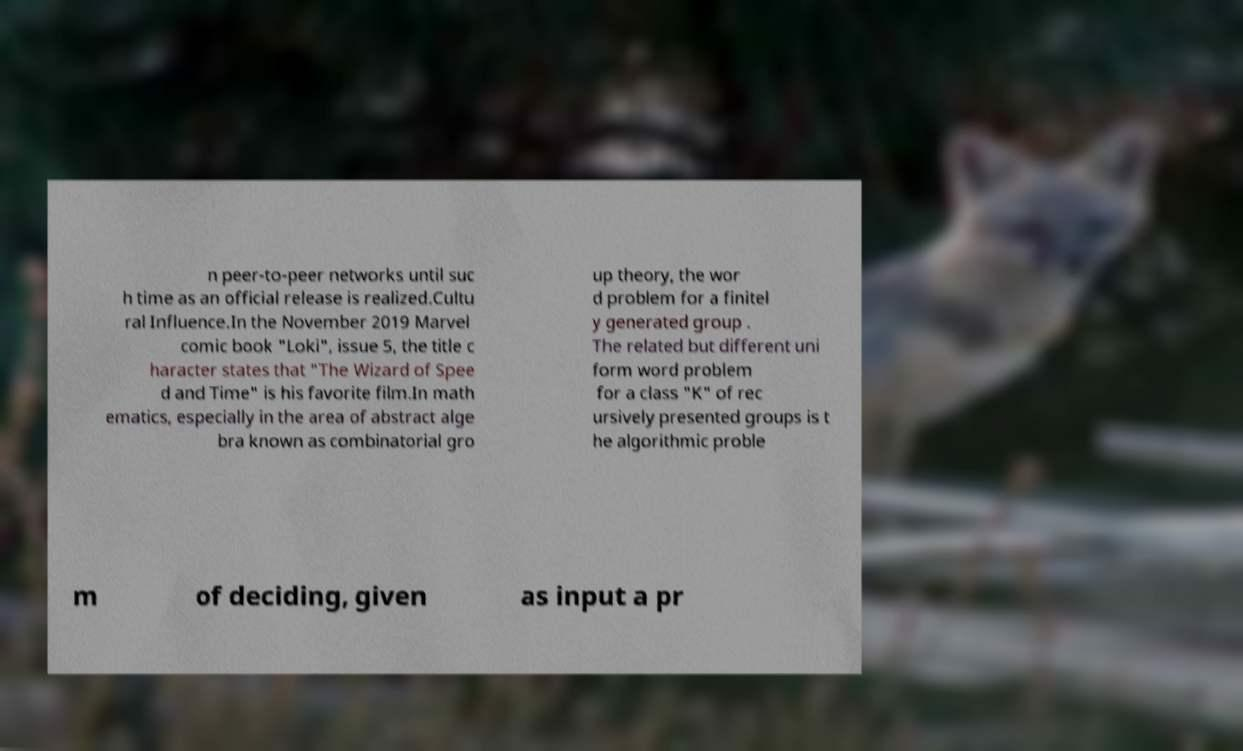Can you accurately transcribe the text from the provided image for me? n peer-to-peer networks until suc h time as an official release is realized.Cultu ral Influence.In the November 2019 Marvel comic book "Loki", issue 5, the title c haracter states that "The Wizard of Spee d and Time" is his favorite film.In math ematics, especially in the area of abstract alge bra known as combinatorial gro up theory, the wor d problem for a finitel y generated group . The related but different uni form word problem for a class "K" of rec ursively presented groups is t he algorithmic proble m of deciding, given as input a pr 